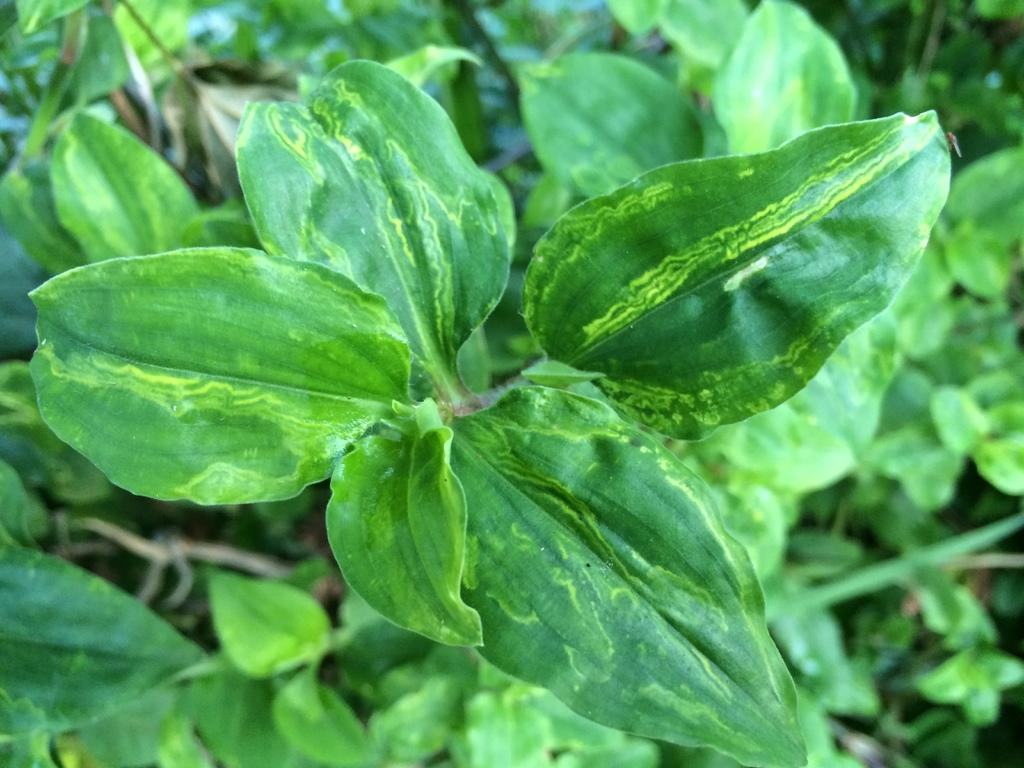What type of living organisms can be seen in the image? Plants can be seen in the image. What type of badge is being worn by the plant in the image? There is no badge present in the image, as it features plants and plants do not wear badges. 